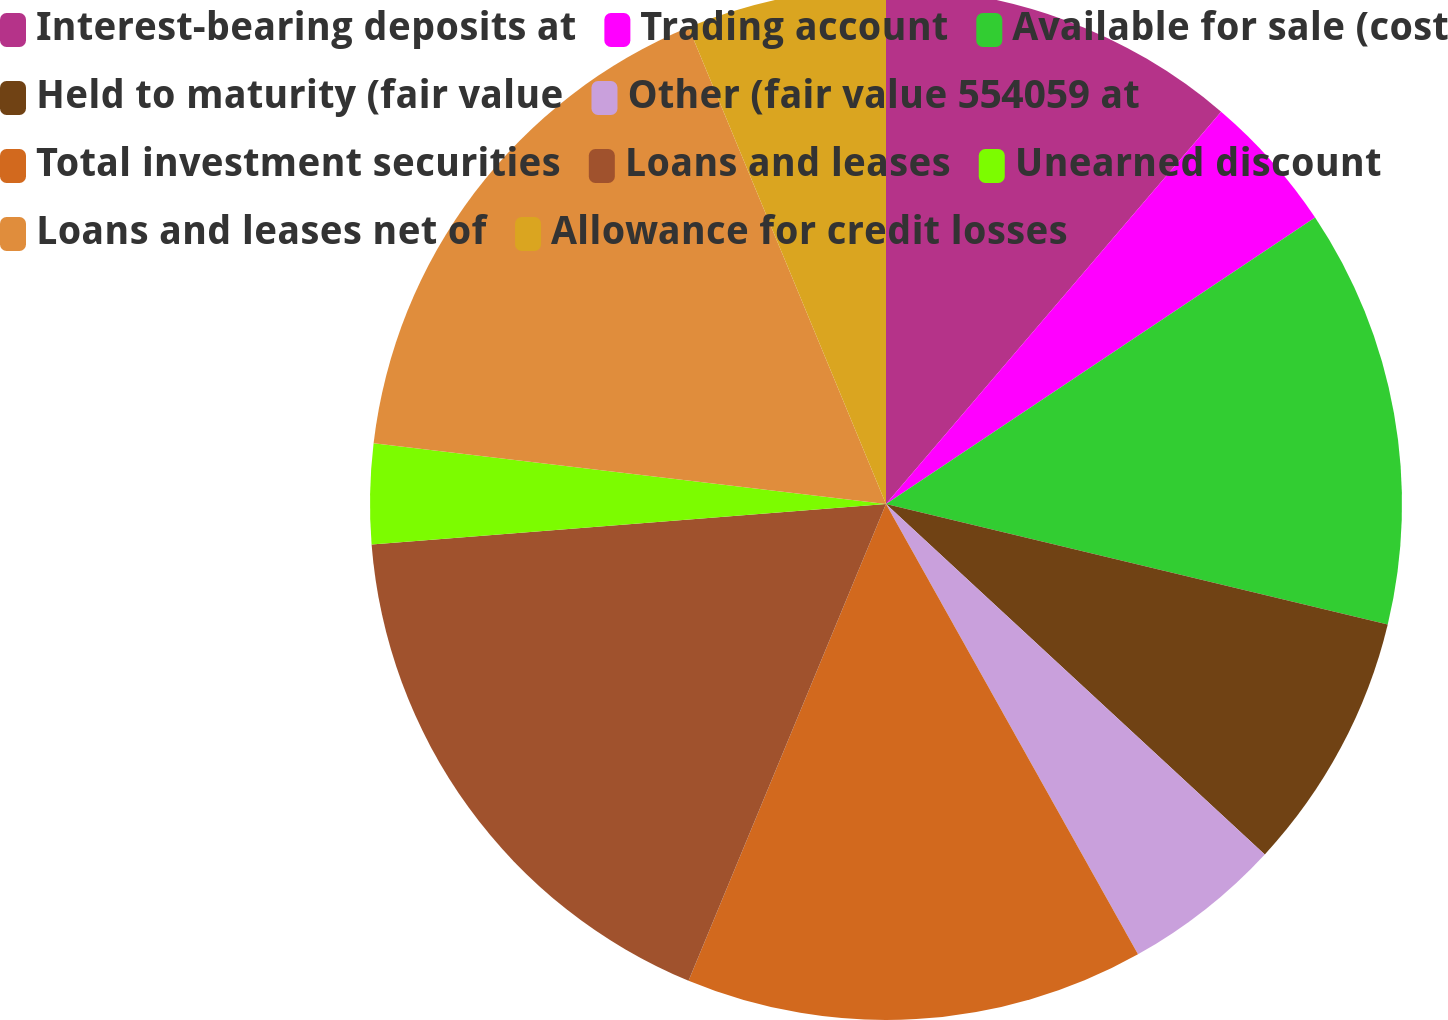Convert chart. <chart><loc_0><loc_0><loc_500><loc_500><pie_chart><fcel>Interest-bearing deposits at<fcel>Trading account<fcel>Available for sale (cost<fcel>Held to maturity (fair value<fcel>Other (fair value 554059 at<fcel>Total investment securities<fcel>Loans and leases<fcel>Unearned discount<fcel>Loans and leases net of<fcel>Allowance for credit losses<nl><fcel>11.25%<fcel>4.38%<fcel>13.12%<fcel>8.13%<fcel>5.0%<fcel>14.37%<fcel>17.5%<fcel>3.13%<fcel>16.87%<fcel>6.25%<nl></chart> 